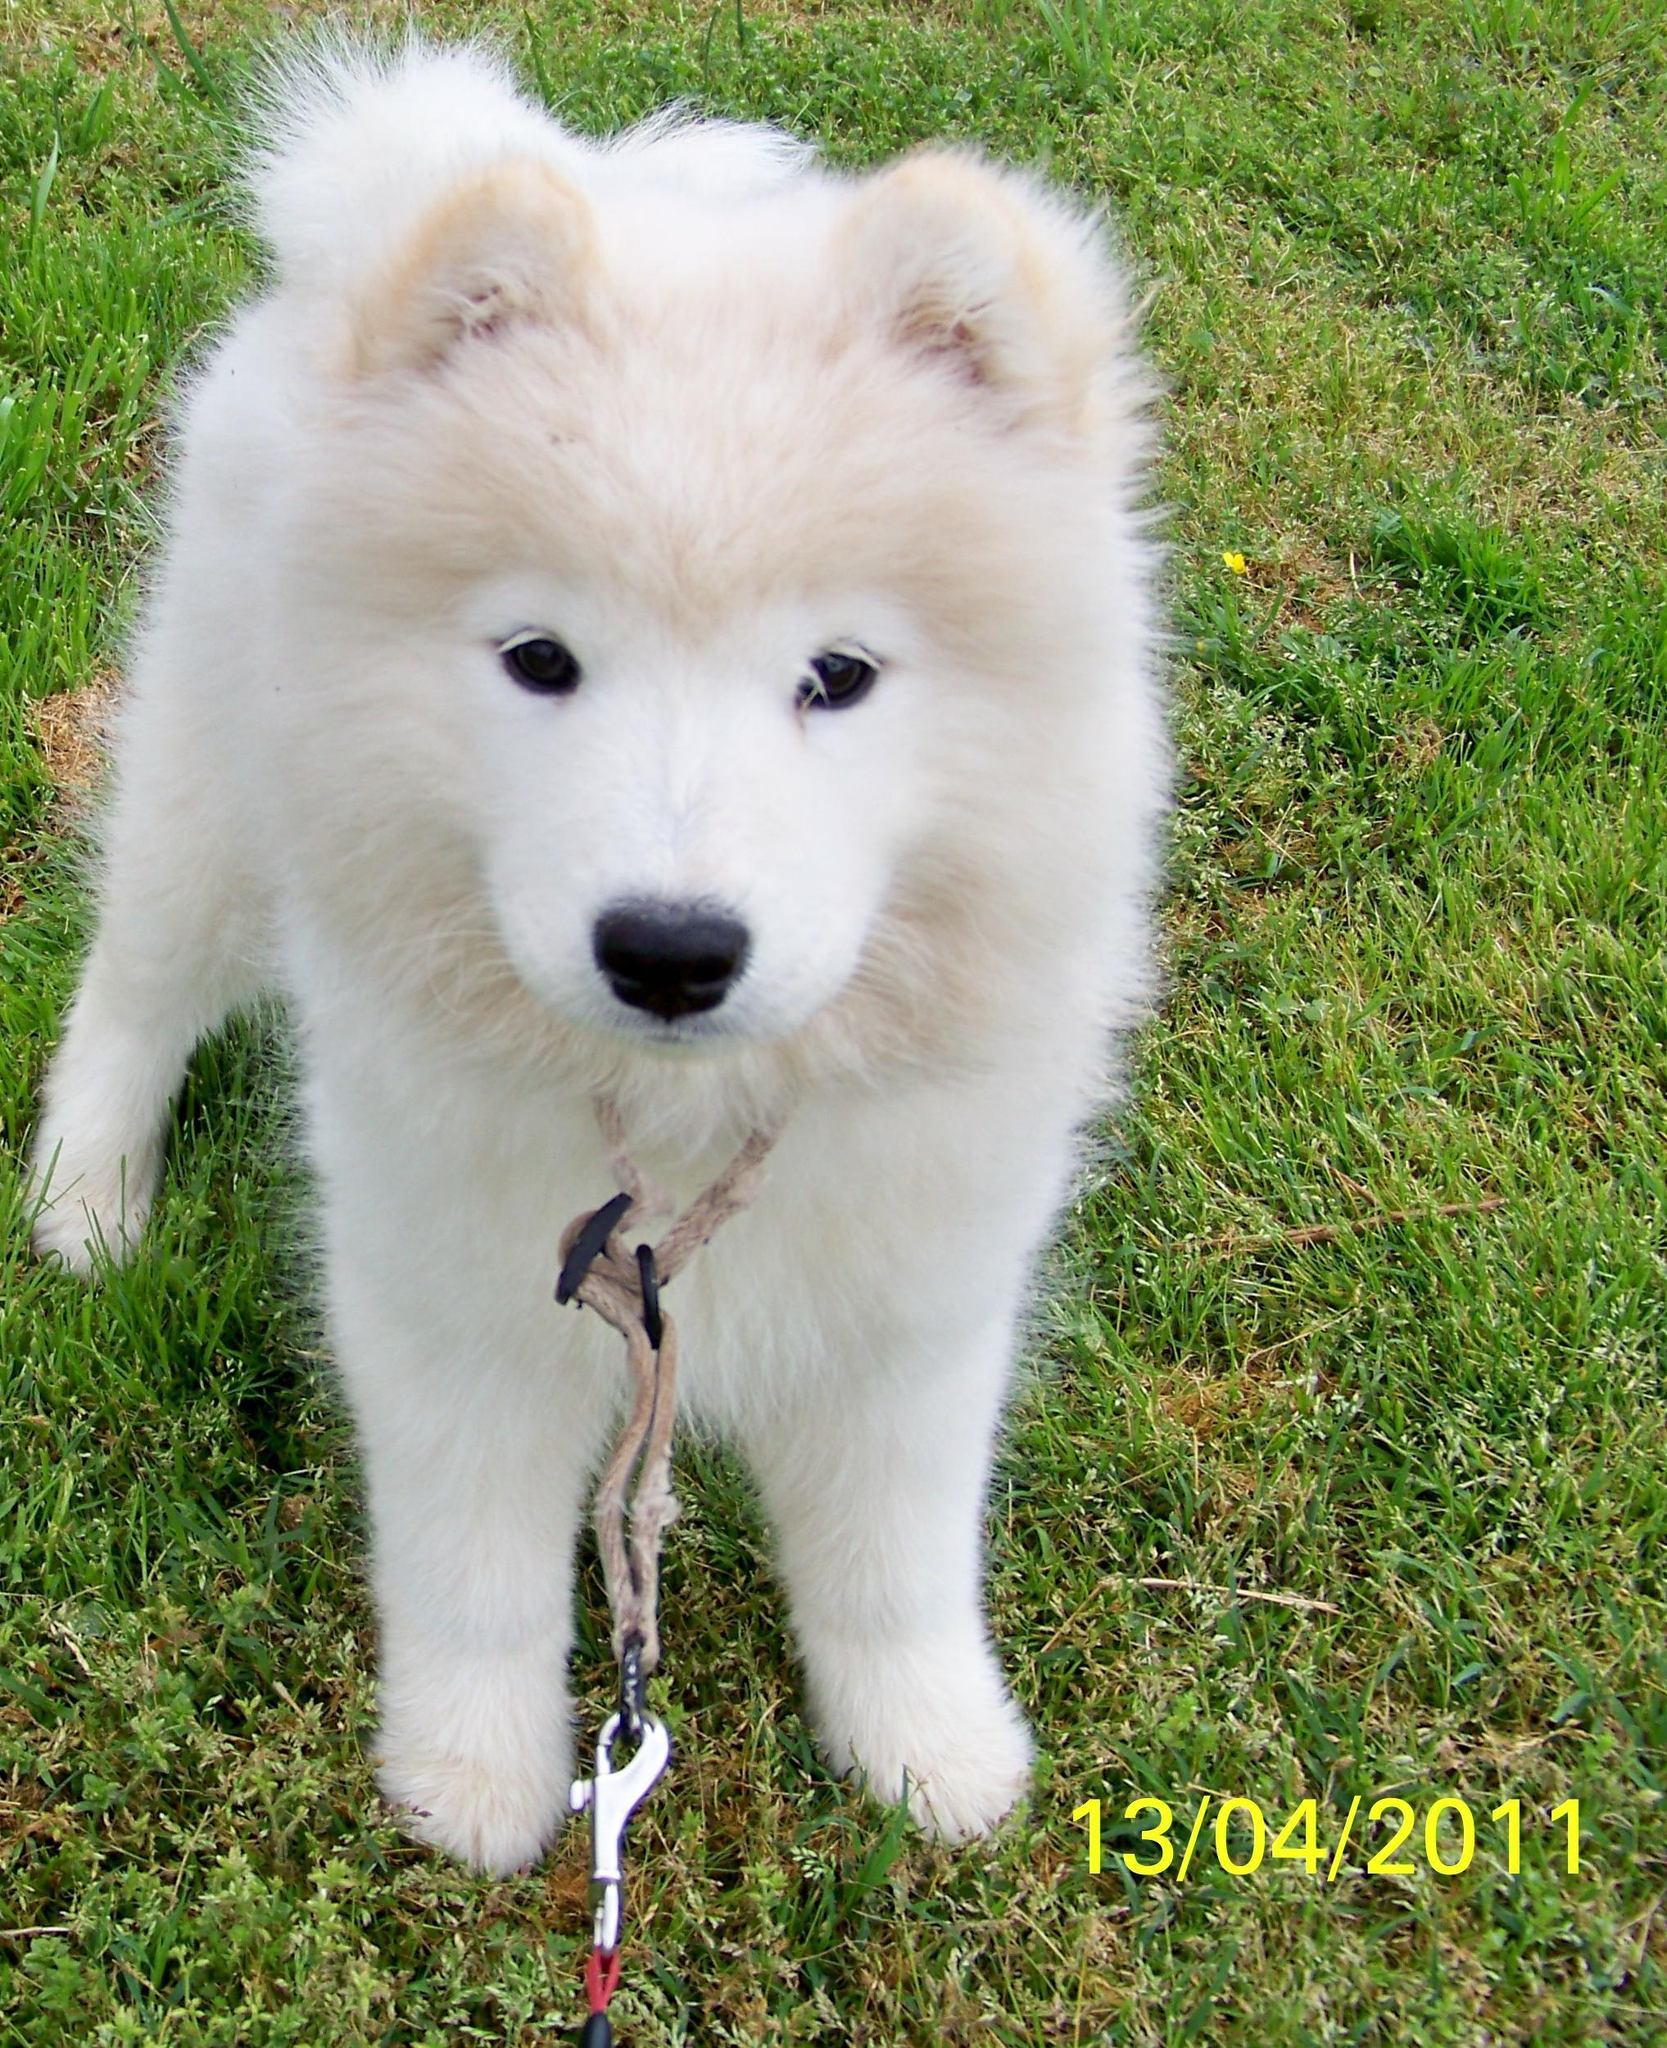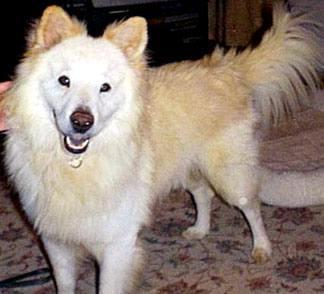The first image is the image on the left, the second image is the image on the right. For the images displayed, is the sentence "An image shows just one fluffy dog standing on grass." factually correct? Answer yes or no. Yes. The first image is the image on the left, the second image is the image on the right. Examine the images to the left and right. Is the description "There is at least one dog facing the camera in the image on the left" accurate? Answer yes or no. Yes. 